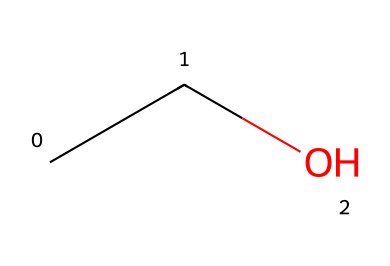What is the molecular formula of this compound? The SMILES representation "CCO" shows that there are 2 carbon atoms (C) and 6 hydrogen atoms (H) along with 1 oxygen atom (O). Therefore, the molecular formula can be derived as C2H6O.
Answer: C2H6O How many carbon atoms are present in this molecule? By looking at the SMILES "CCO," we can identify that there are 2 carbon (C) atoms represented by the two 'C's at the beginning.
Answer: 2 What type of functional group is present in ethanol? The presence of the hydroxyl group (-OH) is indicated by the 'O' at the end of the SMILES "CCO," which is characteristic of alcohols.
Answer: alcohol How many hydrogen atoms are connected to the carbon atoms in this compound? There are 6 hydrogen atoms in total, as deduced from the standard valency of carbon and oxygen in the molecular structure, and confirmed by the SMILES notation.
Answer: 6 What is the primary use of ethanol in fermented beverages like bush beer? Ethanol is primarily used for its intoxicating properties, produced during fermentation. Its presence enhances the flavor profile and affects the beverage's overall effects.
Answer: intoxicant Is ethanol considered a hydrocarbon? Ethanol contains carbon and hydrogen, but it has an oxygen component due to the hydroxyl group, making it an alcohol rather than a simple hydrocarbon.
Answer: no 